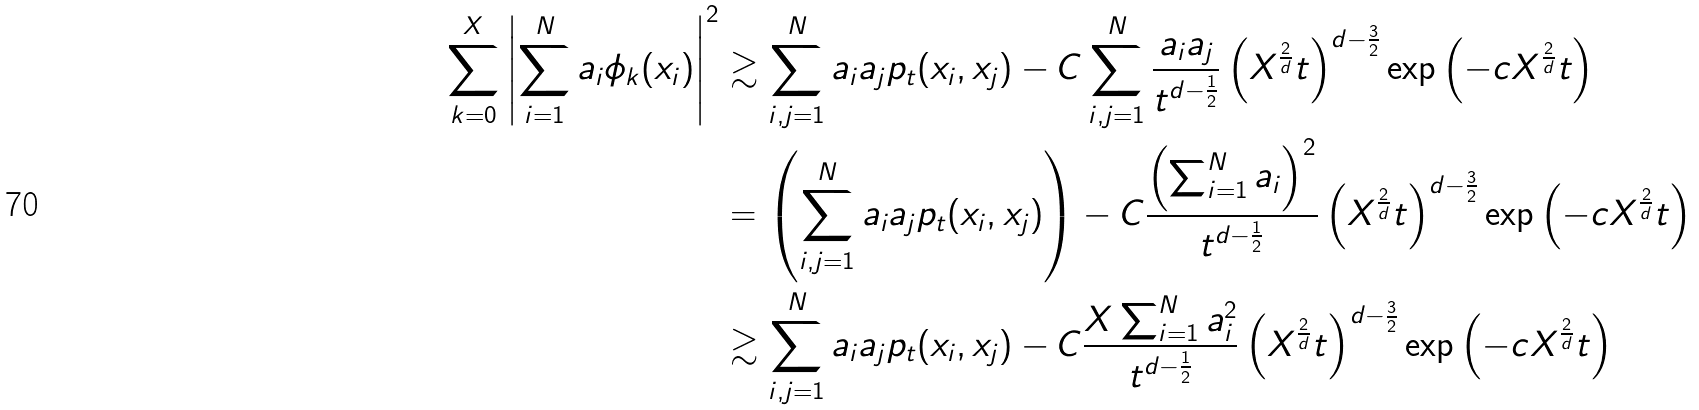Convert formula to latex. <formula><loc_0><loc_0><loc_500><loc_500>\sum _ { k = 0 } ^ { X } \left | \sum _ { i = 1 } ^ { N } { a _ { i } \phi _ { k } ( x _ { i } ) } \right | ^ { 2 } & \gtrsim \sum _ { i , j = 1 } ^ { N } { a _ { i } a _ { j } p _ { t } ( x _ { i } , x _ { j } ) } - C \sum _ { i , j = 1 } ^ { N } { \frac { a _ { i } a _ { j } } { t ^ { d - \frac { 1 } { 2 } } } \left ( X ^ { \frac { 2 } { d } } t \right ) ^ { d - \frac { 3 } { 2 } } \exp \left ( - c X ^ { \frac { 2 } { d } } t \right ) } \\ & = \left ( \sum _ { i , j = 1 } ^ { N } { a _ { i } a _ { j } p _ { t } ( x _ { i } , x _ { j } ) } \right ) - C \frac { \left ( \sum _ { i = 1 } ^ { N } { a _ { i } } \right ) ^ { 2 } } { t ^ { d - \frac { 1 } { 2 } } } \left ( X ^ { \frac { 2 } { d } } t \right ) ^ { d - \frac { 3 } { 2 } } \exp \left ( - c X ^ { \frac { 2 } { d } } t \right ) \\ & \gtrsim \sum _ { i , j = 1 } ^ { N } { a _ { i } a _ { j } p _ { t } ( x _ { i } , x _ { j } ) } - C \frac { X \sum _ { i = 1 } ^ { N } { a _ { i } ^ { 2 } } } { t ^ { d - \frac { 1 } { 2 } } } \left ( X ^ { \frac { 2 } { d } } t \right ) ^ { d - \frac { 3 } { 2 } } \exp \left ( - c X ^ { \frac { 2 } { d } } t \right )</formula> 